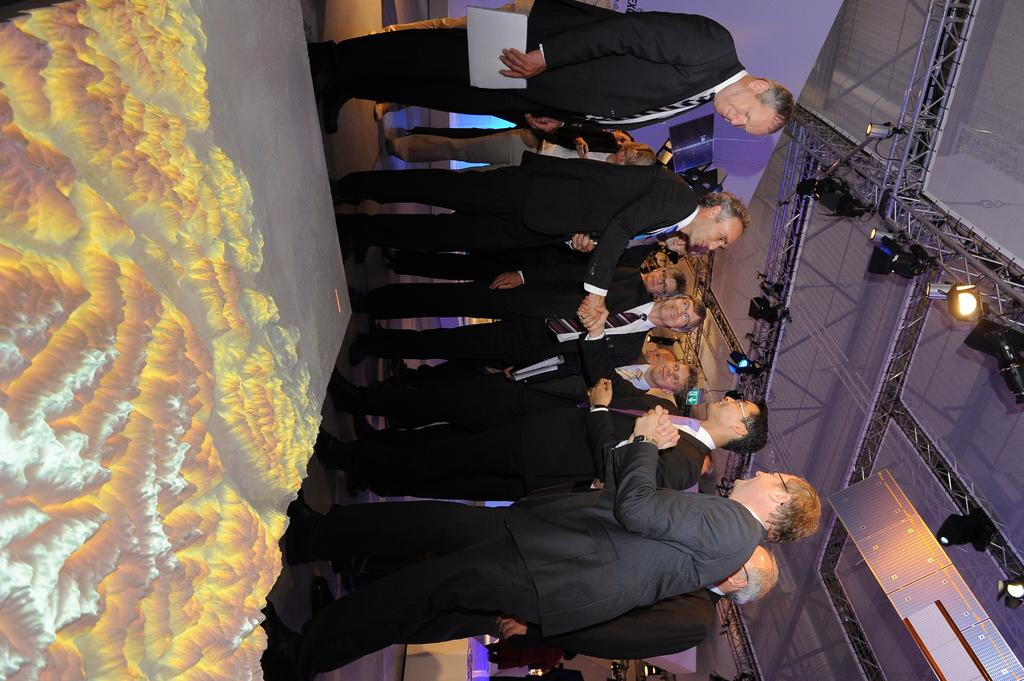What is the main subject in the middle of the image? There is a group of people in the middle of the image. What type of scenery can be seen on the left side of the image? There is a picture of mountains on the left side of the image. What can be found on the right side of the image? There are focus lights and iron frames on the right side of the image. What is visible above the subjects in the image? There is a ceiling visible in the image. What letter is being written on the ceiling in the image? There is no letter being written on the ceiling in the image. What type of oil can be seen dripping from the iron frames in the image? There is no oil present in the image, and the iron frames are not depicted as dripping anything. 